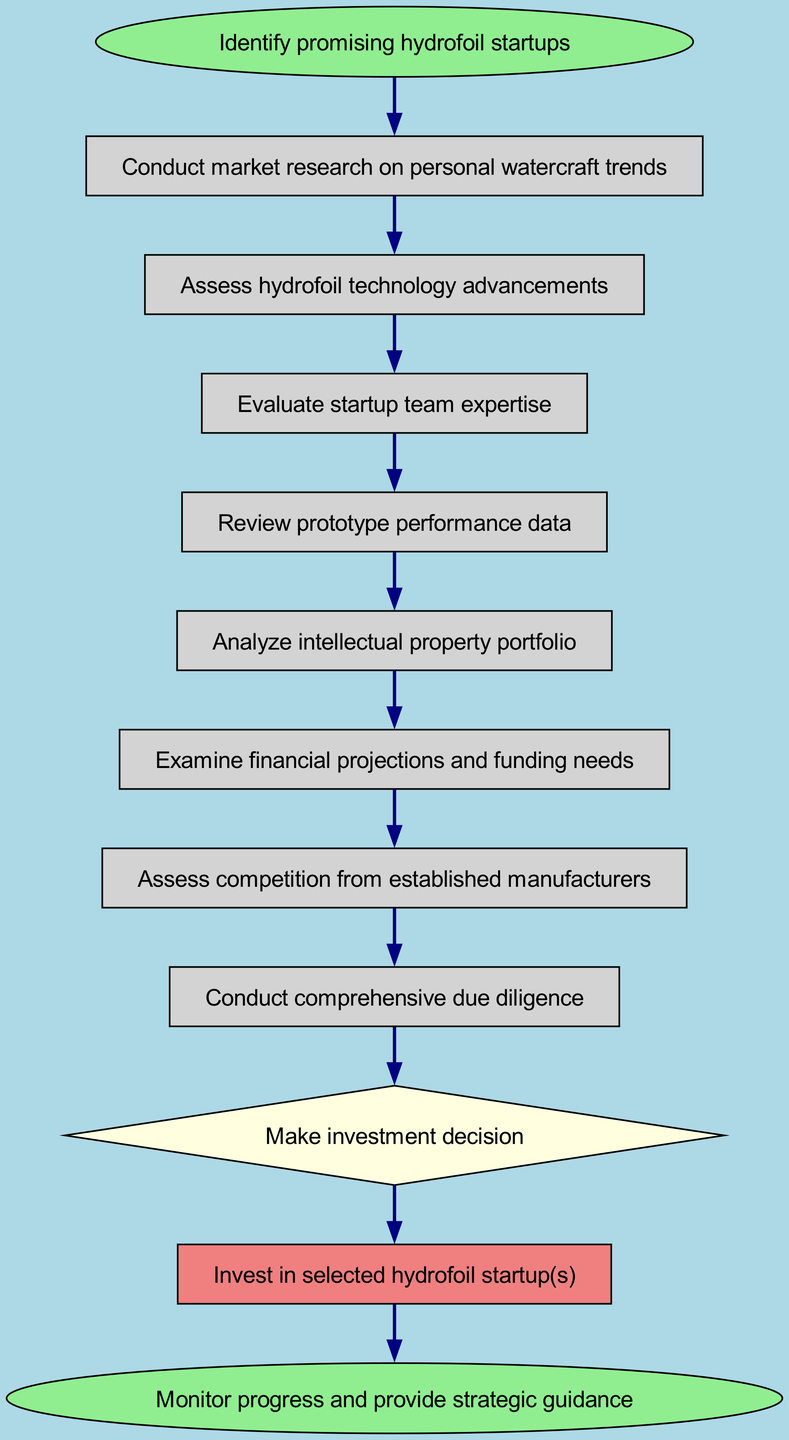What is the first step in the investment decision process? The diagram indicates that the first step, represented as the 'start' node, is "Identify promising hydrofoil startups."
Answer: Identify promising hydrofoil startups How many nodes are present in the diagram? Counting the elements listed in the data, there are a total of 11 distinct nodes in the flow chart.
Answer: 11 What is the last action in the flow of decisions? According to the flow diagram, the last action indicated is "Monitor progress and provide strategic guidance."
Answer: Monitor progress and provide strategic guidance Which node follows the team evaluation step? From the connections presented in the diagram, the node that follows "Evaluate startup team expertise" is "Review prototype performance data."
Answer: Review prototype performance data What shape represents the investment decision point in the diagram? The diagram specifies that the 'decision' node is represented as a diamond shape.
Answer: Diamond What action is taken after conducting comprehensive due diligence? The subsequent action following "Conduct comprehensive due diligence" is to "Make investment decision," as shown in the flow connections.
Answer: Make investment decision Which step involves assessing competitors? The diagram indicates that assessing competition is depicted as the node titled "Assess competition from established manufacturers."
Answer: Assess competition from established manufacturers What is the total number of connections in this flow chart? By examining all the edges connecting the nodes, it becomes clear that there are 10 distinct connections in the flow chart.
Answer: 10 Which step occurs before reviewing the intellectual property portfolio? The flow chart shows that reviewing the prototype performance data takes place right before "Analyze intellectual property portfolio."
Answer: Review prototype performance data 